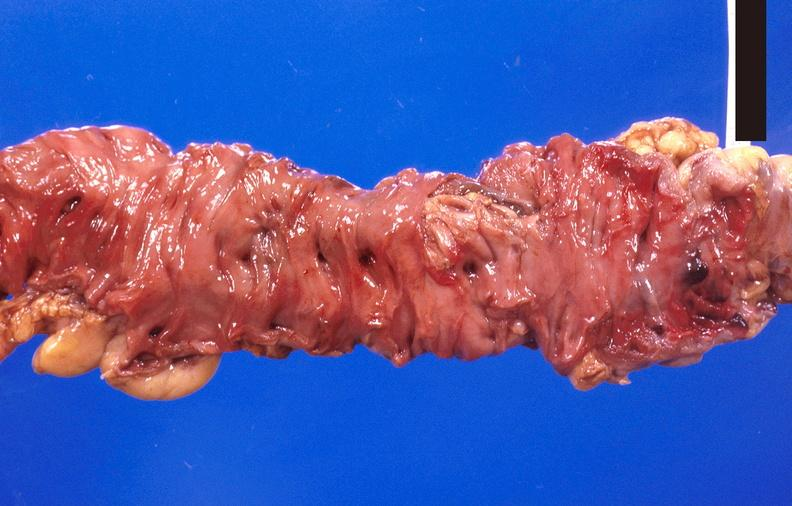where does this belong to?
Answer the question using a single word or phrase. Gastrointestinal system 